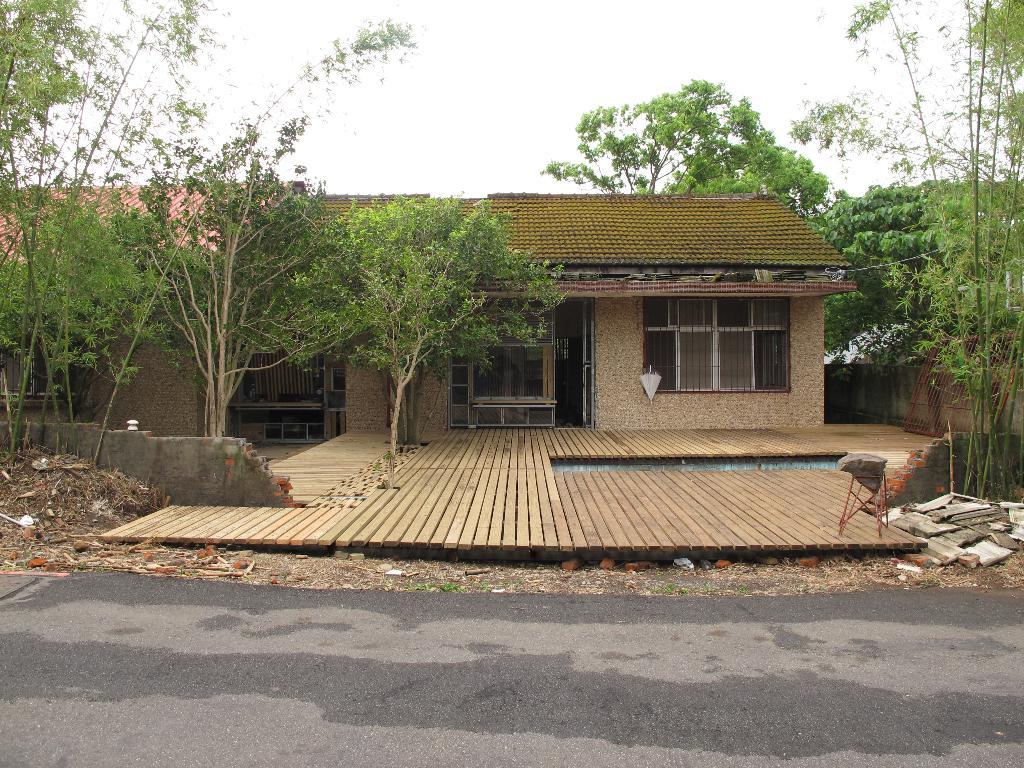What type of structure is visible in the image? There is a house in the image. What other natural elements can be seen in the image? There are trees in the image. What object is present for cooking or barbecuing? There is a grill in the image. What is used for shade in the image? There is an umbrella in the image. What can be seen in the sky in the image? The sky is visible in the image. What riddle is written on the sign in the image? There is no sign present in the image, so no riddle can be read. 